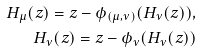<formula> <loc_0><loc_0><loc_500><loc_500>H _ { \mu } ( z ) = z - \phi _ { ( \mu , \nu ) } ( H _ { \nu } ( z ) ) , \\ H _ { \nu } ( z ) = z - \phi _ { \nu } ( H _ { \nu } ( z ) )</formula> 